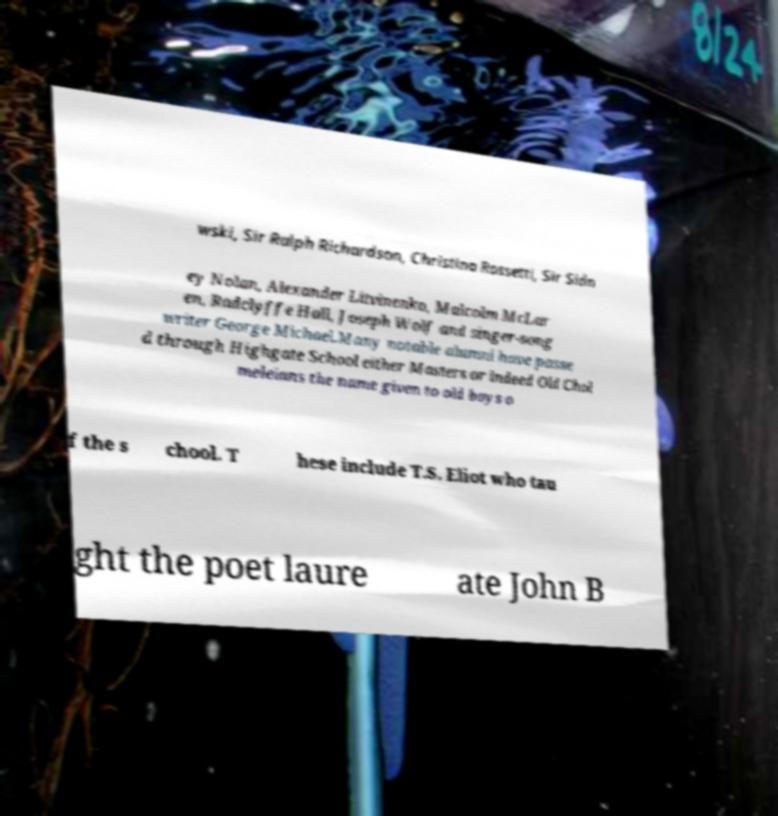Can you read and provide the text displayed in the image?This photo seems to have some interesting text. Can you extract and type it out for me? wski, Sir Ralph Richardson, Christina Rossetti, Sir Sidn ey Nolan, Alexander Litvinenko, Malcolm McLar en, Radclyffe Hall, Joseph Wolf and singer-song writer George Michael.Many notable alumni have passe d through Highgate School either Masters or indeed Old Chol meleians the name given to old boys o f the s chool. T hese include T.S. Eliot who tau ght the poet laure ate John B 